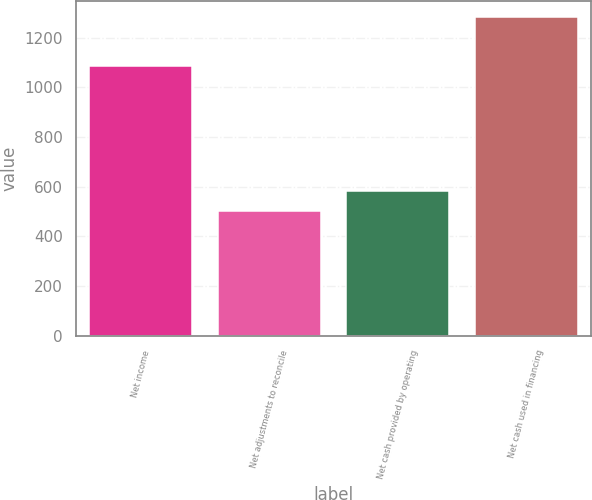Convert chart to OTSL. <chart><loc_0><loc_0><loc_500><loc_500><bar_chart><fcel>Net income<fcel>Net adjustments to reconcile<fcel>Net cash provided by operating<fcel>Net cash used in financing<nl><fcel>1084<fcel>501<fcel>583<fcel>1282<nl></chart> 